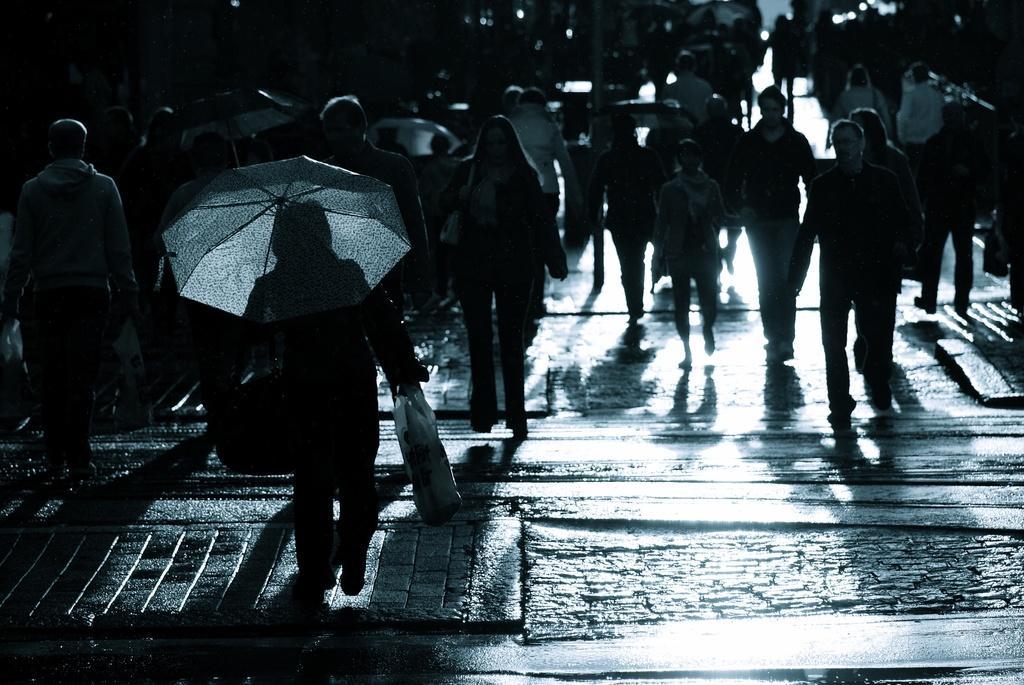In one or two sentences, can you explain what this image depicts? In this picture there is a man who is holding an umbrella and plastic bag. He is walking on the street. In front of him i can see many peoples were walking on the road. In the background we can see the building. 